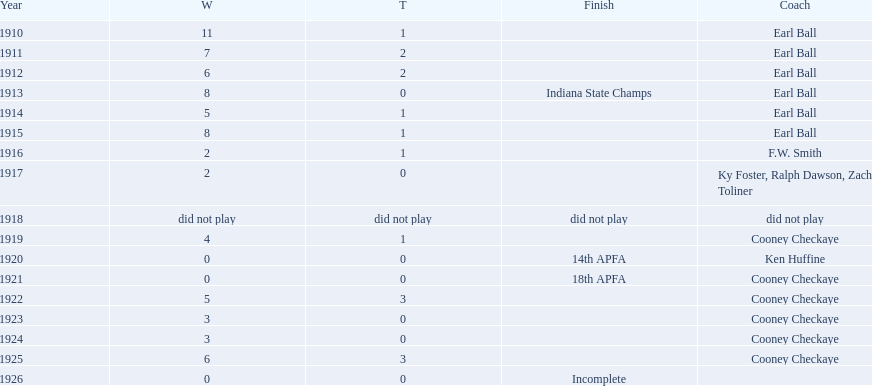How many years did earl ball coach the muncie flyers? 6. 